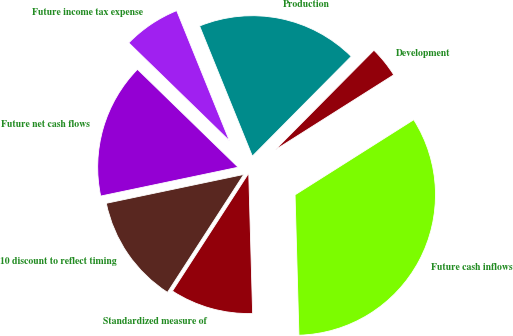Convert chart to OTSL. <chart><loc_0><loc_0><loc_500><loc_500><pie_chart><fcel>Future cash inflows<fcel>Development<fcel>Production<fcel>Future income tax expense<fcel>Future net cash flows<fcel>10 discount to reflect timing<fcel>Standardized measure of<nl><fcel>33.54%<fcel>3.59%<fcel>18.56%<fcel>6.59%<fcel>15.57%<fcel>12.57%<fcel>9.58%<nl></chart> 